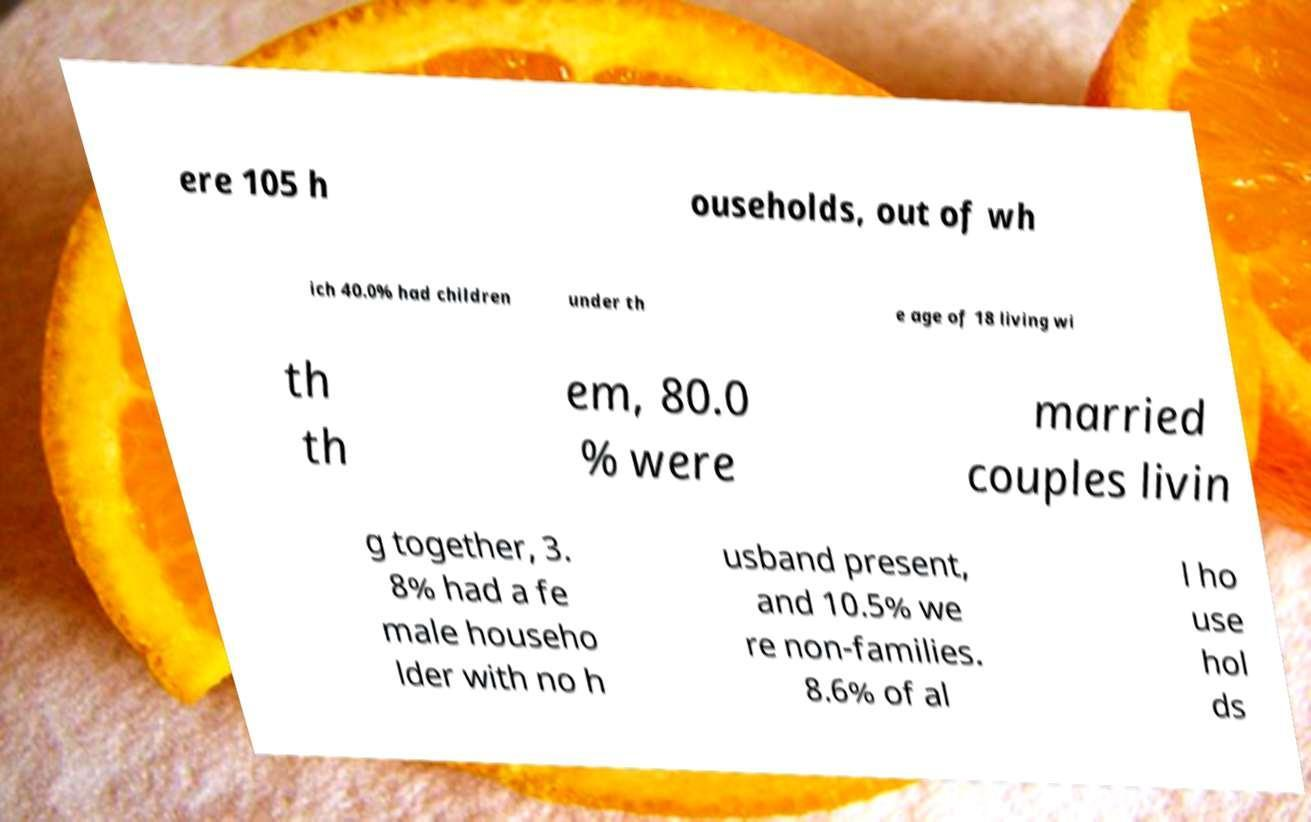Could you assist in decoding the text presented in this image and type it out clearly? ere 105 h ouseholds, out of wh ich 40.0% had children under th e age of 18 living wi th th em, 80.0 % were married couples livin g together, 3. 8% had a fe male househo lder with no h usband present, and 10.5% we re non-families. 8.6% of al l ho use hol ds 